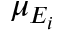<formula> <loc_0><loc_0><loc_500><loc_500>\mu _ { E _ { i } }</formula> 